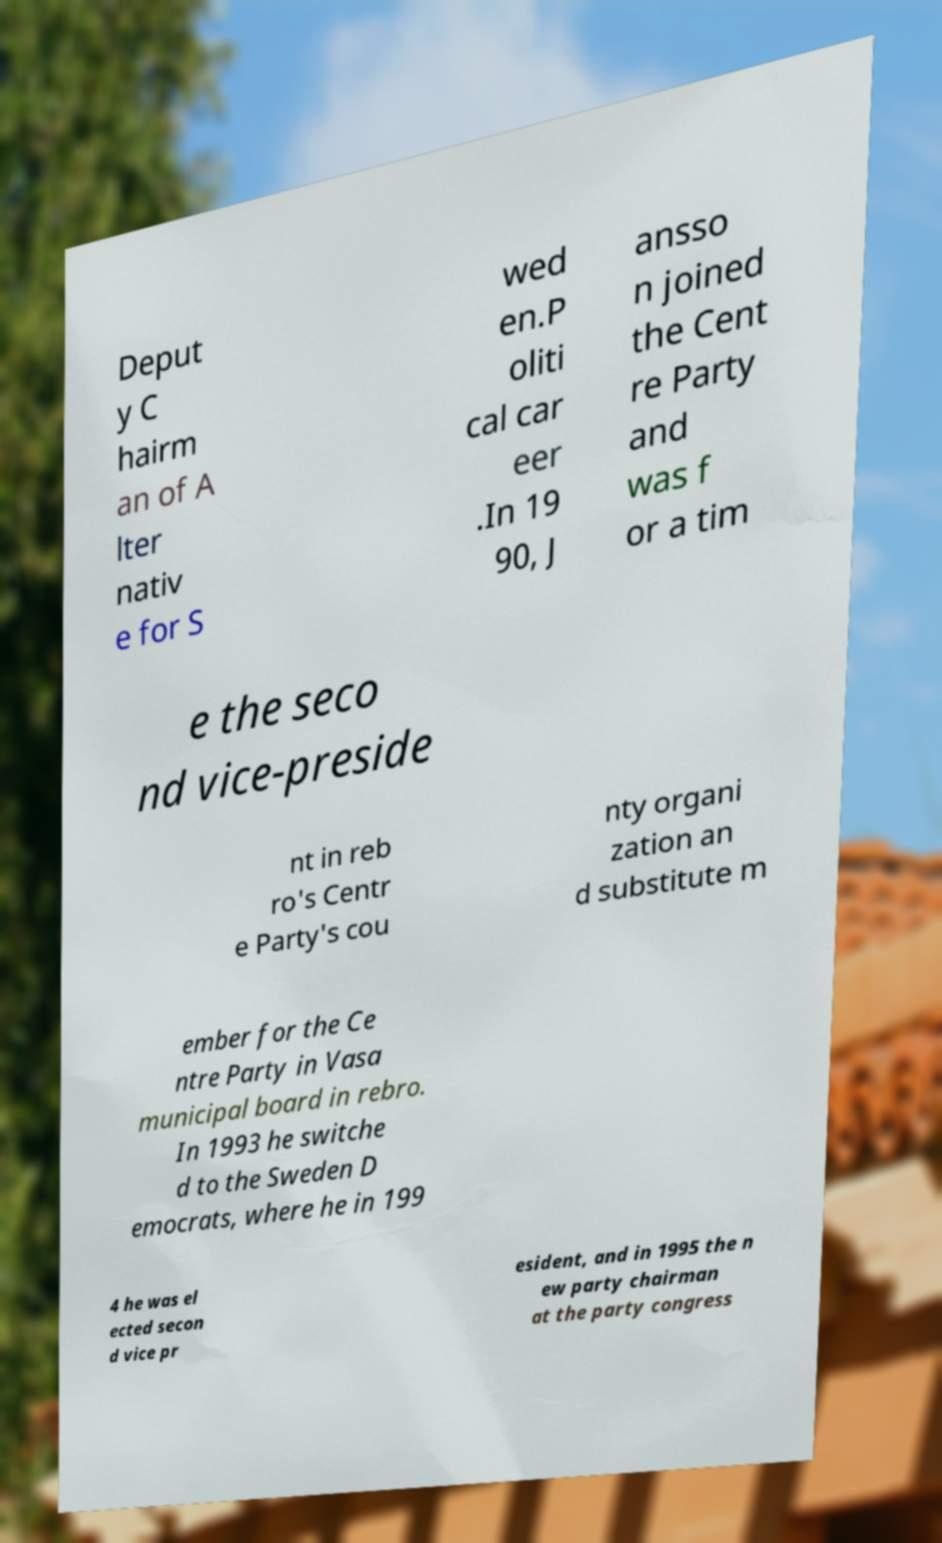I need the written content from this picture converted into text. Can you do that? Deput y C hairm an of A lter nativ e for S wed en.P oliti cal car eer .In 19 90, J ansso n joined the Cent re Party and was f or a tim e the seco nd vice-preside nt in reb ro's Centr e Party's cou nty organi zation an d substitute m ember for the Ce ntre Party in Vasa municipal board in rebro. In 1993 he switche d to the Sweden D emocrats, where he in 199 4 he was el ected secon d vice pr esident, and in 1995 the n ew party chairman at the party congress 